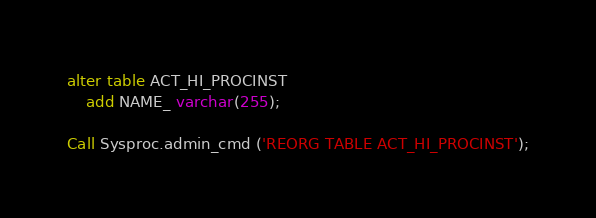<code> <loc_0><loc_0><loc_500><loc_500><_SQL_>alter table ACT_HI_PROCINST
	add NAME_ varchar(255);
	
Call Sysproc.admin_cmd ('REORG TABLE ACT_HI_PROCINST');
</code> 